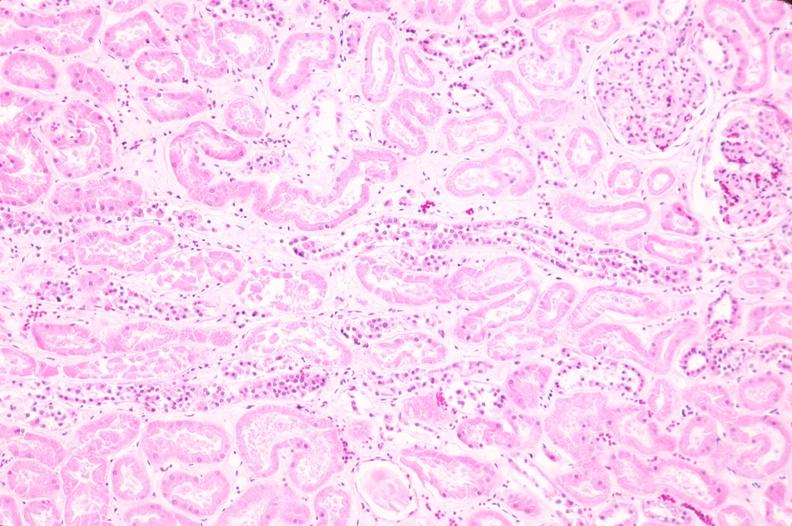does linear fracture in occiput show kidney, acute tubular necrosis?
Answer the question using a single word or phrase. No 